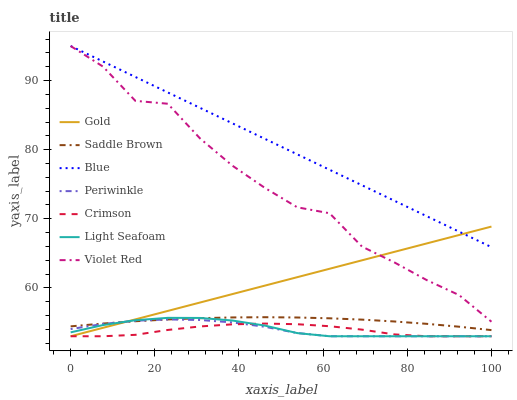Does Crimson have the minimum area under the curve?
Answer yes or no. Yes. Does Blue have the maximum area under the curve?
Answer yes or no. Yes. Does Violet Red have the minimum area under the curve?
Answer yes or no. No. Does Violet Red have the maximum area under the curve?
Answer yes or no. No. Is Gold the smoothest?
Answer yes or no. Yes. Is Violet Red the roughest?
Answer yes or no. Yes. Is Violet Red the smoothest?
Answer yes or no. No. Is Gold the roughest?
Answer yes or no. No. Does Violet Red have the lowest value?
Answer yes or no. No. Does Gold have the highest value?
Answer yes or no. No. Is Periwinkle less than Blue?
Answer yes or no. Yes. Is Blue greater than Light Seafoam?
Answer yes or no. Yes. Does Periwinkle intersect Blue?
Answer yes or no. No. 